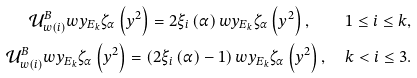Convert formula to latex. <formula><loc_0><loc_0><loc_500><loc_500>\mathcal { U } _ { w \left ( i \right ) } ^ { B } w y _ { E _ { k } } \zeta _ { \alpha } \left ( y ^ { 2 } \right ) = 2 \xi _ { i } \left ( \alpha \right ) w y _ { E _ { k } } \zeta _ { \alpha } \left ( y ^ { 2 } \right ) , \quad 1 \leq i \leq k , \\ \mathcal { U } _ { w \left ( i \right ) } ^ { B } w y _ { E _ { k } } \zeta _ { \alpha } \left ( y ^ { 2 } \right ) = \left ( 2 \xi _ { i } \left ( \alpha \right ) - 1 \right ) w y _ { E _ { k } } \zeta _ { \alpha } \left ( y ^ { 2 } \right ) , \quad k < i \leq 3 .</formula> 